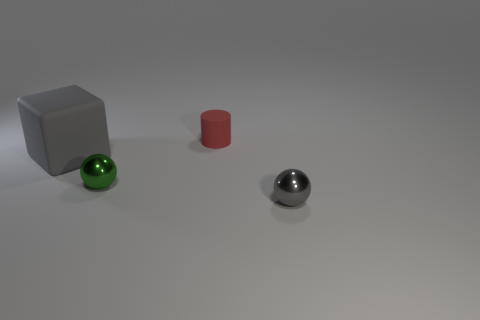What is the color of the rubber cube?
Make the answer very short. Gray. Is the material of the tiny green thing the same as the tiny thing that is right of the red object?
Make the answer very short. Yes. What is the shape of the tiny red object that is made of the same material as the large cube?
Give a very brief answer. Cylinder. The matte object that is the same size as the gray metal sphere is what color?
Your answer should be compact. Red. There is a thing that is left of the green metal ball; is its size the same as the cylinder?
Your response must be concise. No. Does the small cylinder have the same color as the big thing?
Your answer should be very brief. No. How many tiny green metal objects are there?
Your answer should be very brief. 1. What number of spheres are either big things or red objects?
Ensure brevity in your answer.  0. There is a rubber thing that is behind the large gray matte thing; what number of red rubber cylinders are in front of it?
Ensure brevity in your answer.  0. Are the gray cube and the gray ball made of the same material?
Offer a terse response. No. 